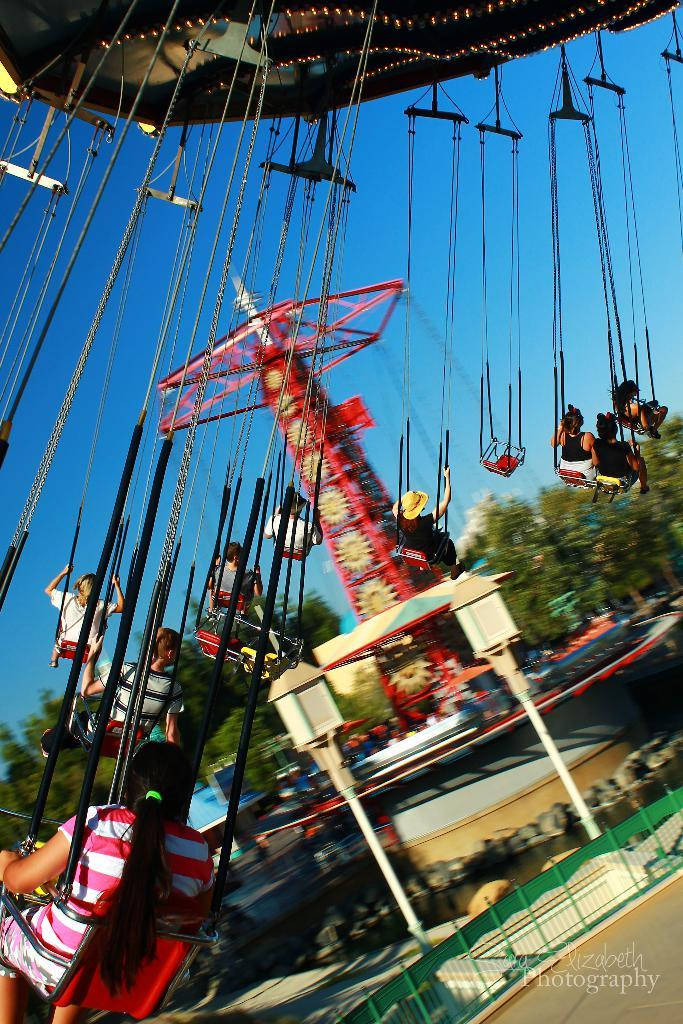What activity are the persons in the image engaged in? The persons in the image are riding a swing. Can you describe another fun ride in the image? There is another fun ride in the image, but its specific details are not mentioned in the facts. What can be seen in the middle of the image? There are trees in the middle of the image. What is visible in the background of the image? The sky is visible in the background of the image. What type of cake is being served at the picnic in the image? There is no picnic or cake present in the image; it features persons riding a swing and another fun ride, with trees and the sky visible in the background. 